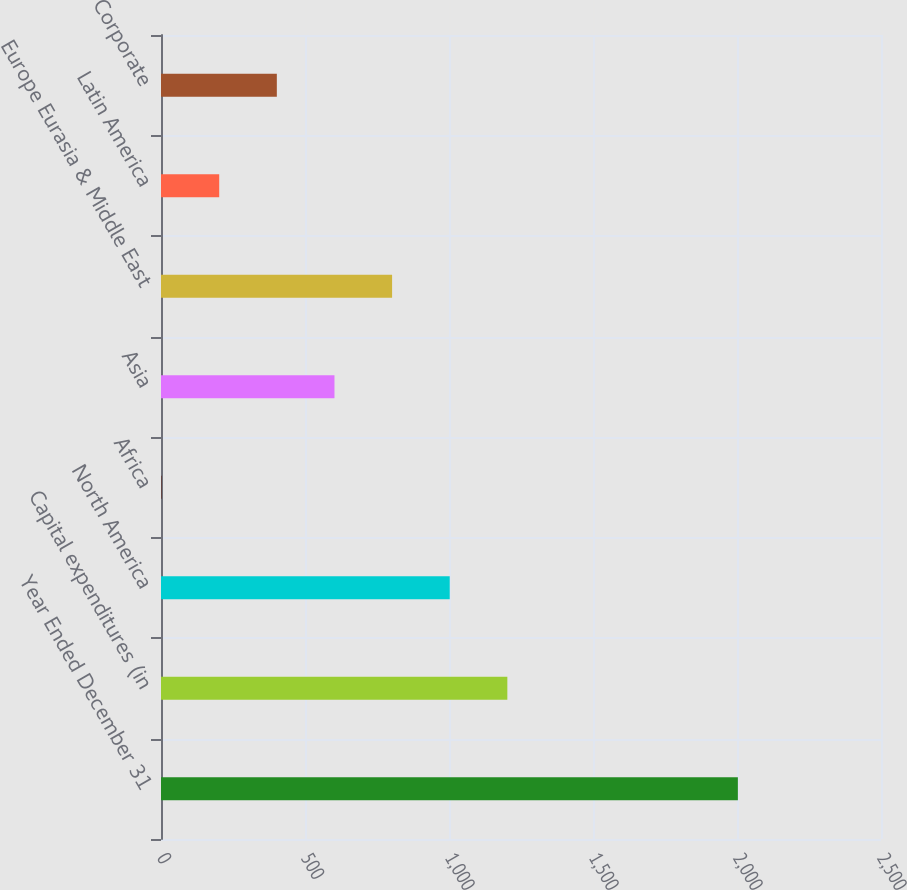Convert chart. <chart><loc_0><loc_0><loc_500><loc_500><bar_chart><fcel>Year Ended December 31<fcel>Capital expenditures (in<fcel>North America<fcel>Africa<fcel>Asia<fcel>Europe Eurasia & Middle East<fcel>Latin America<fcel>Corporate<nl><fcel>2003<fcel>1202.6<fcel>1002.5<fcel>2<fcel>602.3<fcel>802.4<fcel>202.1<fcel>402.2<nl></chart> 